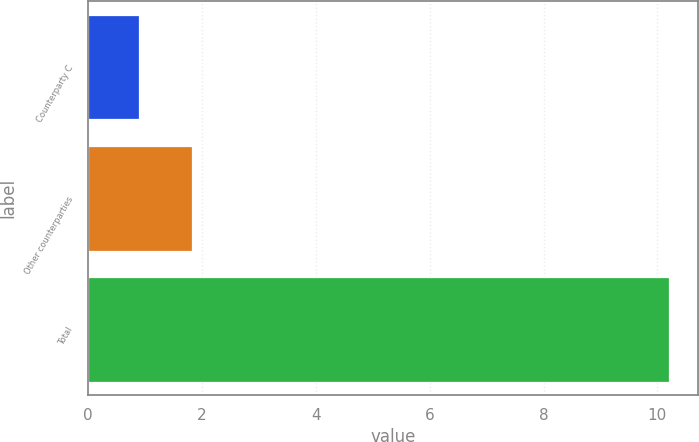Convert chart. <chart><loc_0><loc_0><loc_500><loc_500><bar_chart><fcel>Counterparty C<fcel>Other counterparties<fcel>Total<nl><fcel>0.9<fcel>1.83<fcel>10.2<nl></chart> 